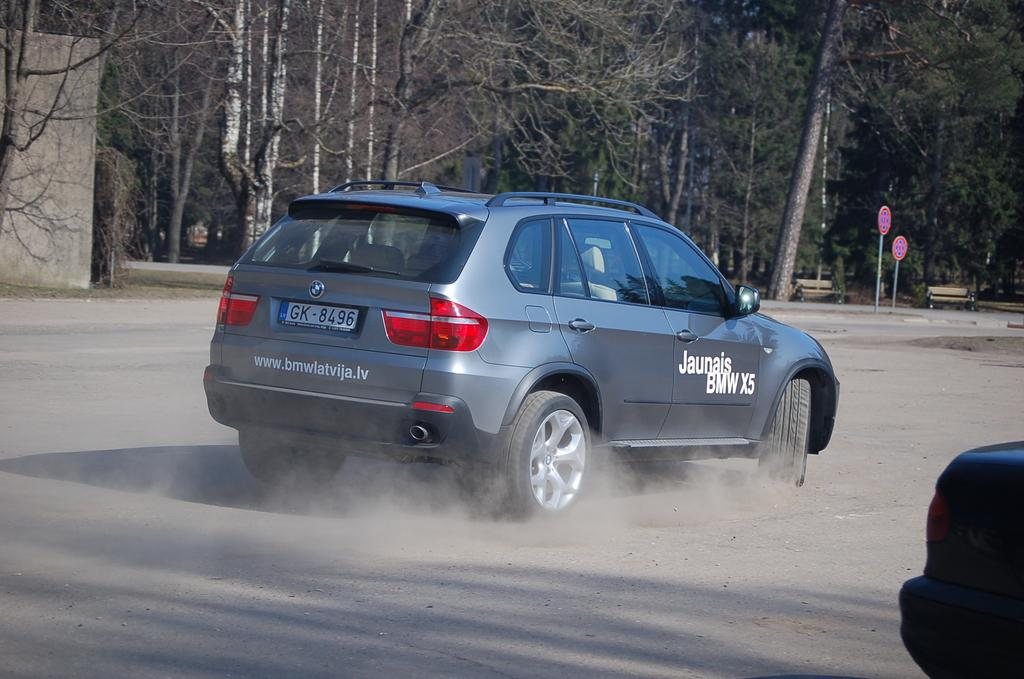<image>
Write a terse but informative summary of the picture. A silver BMW is driving in a dirt lot and says Jaunais BMW X5 on the side. 